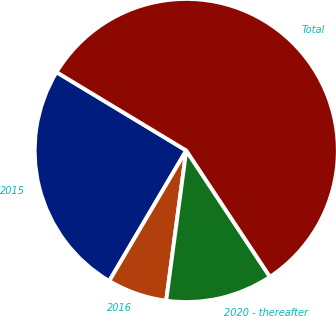Convert chart. <chart><loc_0><loc_0><loc_500><loc_500><pie_chart><fcel>2015<fcel>2016<fcel>2020 - thereafter<fcel>Total<nl><fcel>25.16%<fcel>6.37%<fcel>11.43%<fcel>57.04%<nl></chart> 